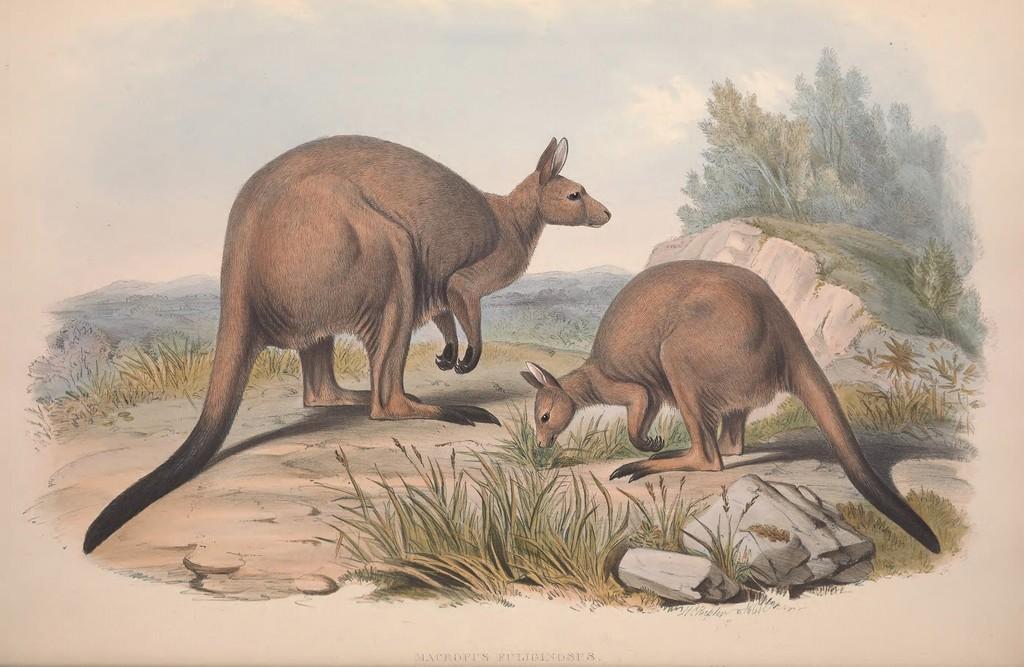Can you describe this image briefly? In the center of the image there are animals. At the bottom there is grass and rocks. In the background there are trees, hills and sky. 